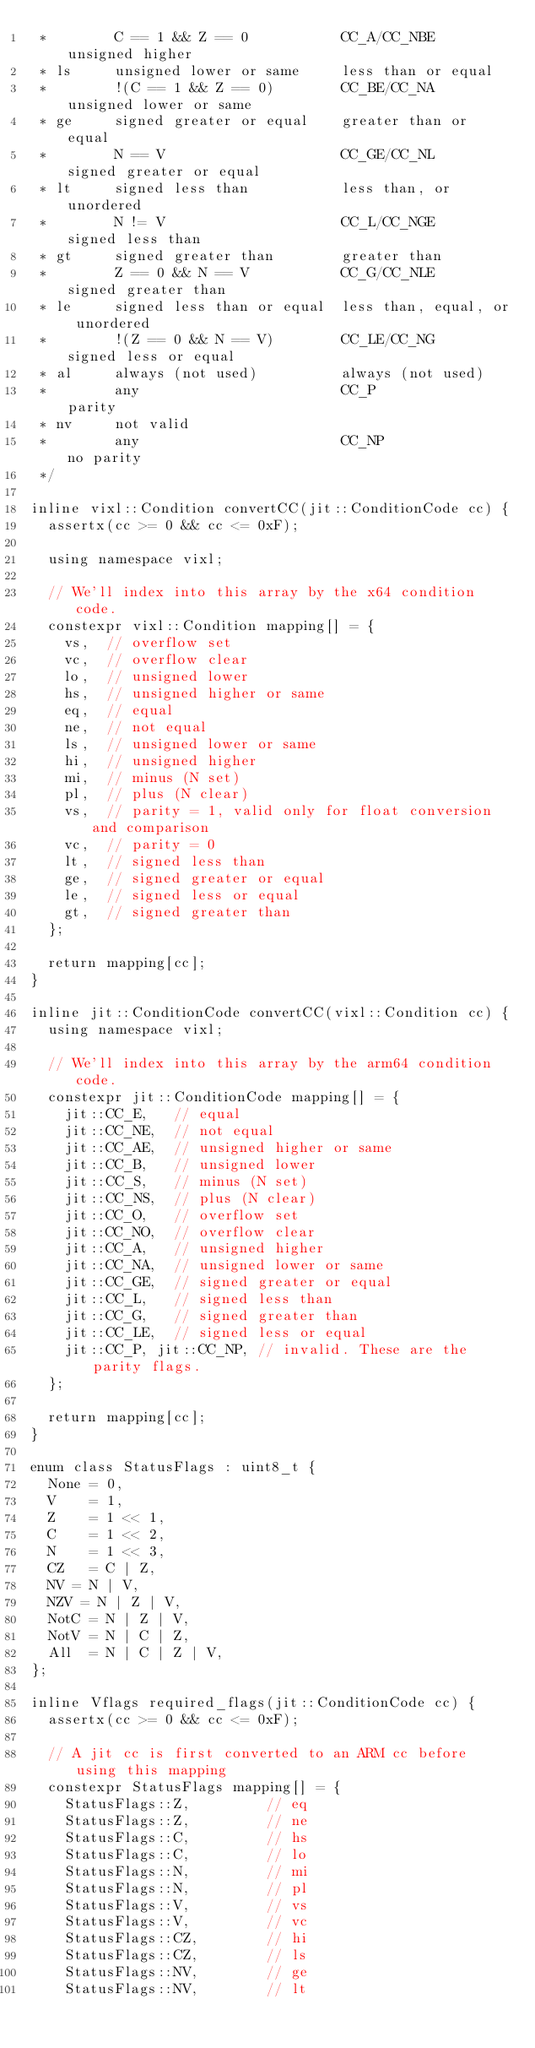<code> <loc_0><loc_0><loc_500><loc_500><_C_> *        C == 1 && Z == 0           CC_A/CC_NBE        unsigned higher
 * ls     unsigned lower or same     less than or equal
 *        !(C == 1 && Z == 0)        CC_BE/CC_NA        unsigned lower or same
 * ge     signed greater or equal    greater than or equal
 *        N == V                     CC_GE/CC_NL        signed greater or equal
 * lt     signed less than           less than, or unordered
 *        N != V                     CC_L/CC_NGE        signed less than
 * gt     signed greater than        greater than
 *        Z == 0 && N == V           CC_G/CC_NLE        signed greater than
 * le     signed less than or equal  less than, equal, or unordered
 *        !(Z == 0 && N == V)        CC_LE/CC_NG        signed less or equal
 * al     always (not used)          always (not used)
 *        any                        CC_P               parity
 * nv     not valid
 *        any                        CC_NP              no parity
 */

inline vixl::Condition convertCC(jit::ConditionCode cc) {
  assertx(cc >= 0 && cc <= 0xF);

  using namespace vixl;

  // We'll index into this array by the x64 condition code.
  constexpr vixl::Condition mapping[] = {
    vs,  // overflow set
    vc,  // overflow clear
    lo,  // unsigned lower
    hs,  // unsigned higher or same
    eq,  // equal
    ne,  // not equal
    ls,  // unsigned lower or same
    hi,  // unsigned higher
    mi,  // minus (N set)
    pl,  // plus (N clear)
    vs,  // parity = 1, valid only for float conversion and comparison
    vc,  // parity = 0
    lt,  // signed less than
    ge,  // signed greater or equal
    le,  // signed less or equal
    gt,  // signed greater than
  };

  return mapping[cc];
}

inline jit::ConditionCode convertCC(vixl::Condition cc) {
  using namespace vixl;

  // We'll index into this array by the arm64 condition code.
  constexpr jit::ConditionCode mapping[] = {
    jit::CC_E,   // equal
    jit::CC_NE,  // not equal
    jit::CC_AE,  // unsigned higher or same
    jit::CC_B,   // unsigned lower
    jit::CC_S,   // minus (N set)
    jit::CC_NS,  // plus (N clear)
    jit::CC_O,   // overflow set
    jit::CC_NO,  // overflow clear
    jit::CC_A,   // unsigned higher
    jit::CC_NA,  // unsigned lower or same
    jit::CC_GE,  // signed greater or equal
    jit::CC_L,   // signed less than
    jit::CC_G,   // signed greater than
    jit::CC_LE,  // signed less or equal
    jit::CC_P, jit::CC_NP, // invalid. These are the parity flags.
  };

  return mapping[cc];
}

enum class StatusFlags : uint8_t {
  None = 0,
  V    = 1,
  Z    = 1 << 1,
  C    = 1 << 2,
  N    = 1 << 3,
  CZ   = C | Z,
  NV = N | V,
  NZV = N | Z | V,
  NotC = N | Z | V,
  NotV = N | C | Z,
  All  = N | C | Z | V,
};

inline Vflags required_flags(jit::ConditionCode cc) {
  assertx(cc >= 0 && cc <= 0xF);

  // A jit cc is first converted to an ARM cc before using this mapping
  constexpr StatusFlags mapping[] = {
    StatusFlags::Z,         // eq
    StatusFlags::Z,         // ne
    StatusFlags::C,         // hs
    StatusFlags::C,         // lo
    StatusFlags::N,         // mi
    StatusFlags::N,         // pl
    StatusFlags::V,         // vs
    StatusFlags::V,         // vc
    StatusFlags::CZ,        // hi
    StatusFlags::CZ,        // ls
    StatusFlags::NV,        // ge
    StatusFlags::NV,        // lt</code> 